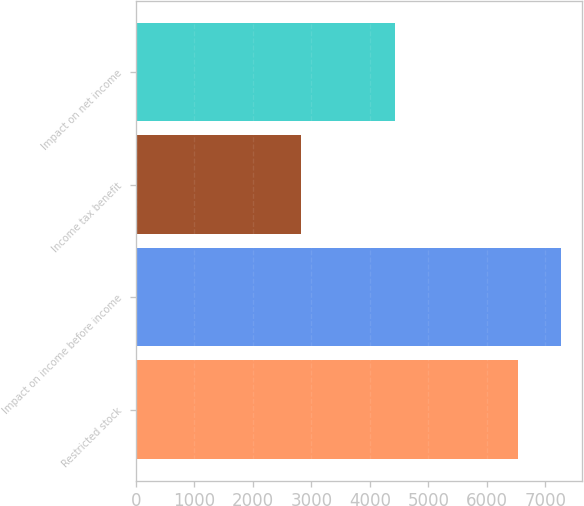Convert chart. <chart><loc_0><loc_0><loc_500><loc_500><bar_chart><fcel>Restricted stock<fcel>Impact on income before income<fcel>Income tax benefit<fcel>Impact on net income<nl><fcel>6541<fcel>7261<fcel>2827<fcel>4434<nl></chart> 